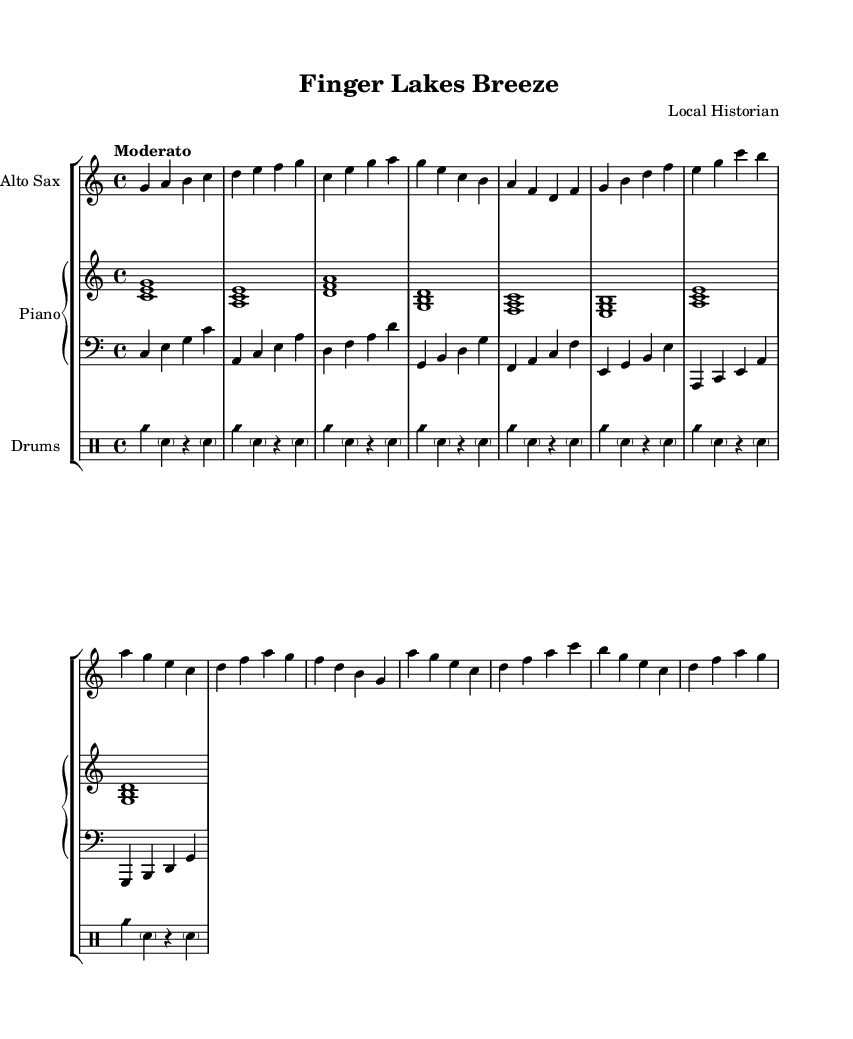What is the key signature of this music? The key signature is C major, which is denoted by the absence of any sharps or flats in the key signature at the beginning of the music.
Answer: C major What is the time signature of this piece? The time signature is 4/4, which is indicated by the "4/4" notation at the beginning of the score, specifying that there are four beats in each measure and the quarter note gets one beat.
Answer: 4/4 What is the tempo marking for this piece? The tempo marking is "Moderato," which suggests a moderate pace, and it is written directly above the staff at the beginning of the score.
Answer: Moderato Which instrument has the melody throughout this piece? The melody is primarily carried by the Alto Saxophone, as portrayed in the treble clef staff designated for that instrument.
Answer: Alto Saxophone What chords are used in the piano part during the first measure? The first measure of the piano part features the chords C major, represented by the notes C, E, and G played together.
Answer: C major How many sections are in the musical piece? The piece contains three distinct sections labeled as A, B, and C, which can be inferred from the structure and repetition of the musical phrases.
Answer: Three What type of jazz is reflected in this piece? This piece reflects "Cool Jazz," which is characterized by a soft, laid-back style and harmonically complex arrangements, as evident from the rich harmonies and smooth melodies throughout the score.
Answer: Cool Jazz 